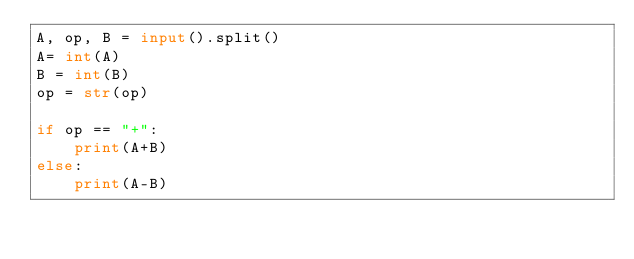Convert code to text. <code><loc_0><loc_0><loc_500><loc_500><_Python_>A, op, B = input().split()
A= int(A)
B = int(B)
op = str(op)

if op == "+":
    print(A+B)
else:
    print(A-B)
</code> 